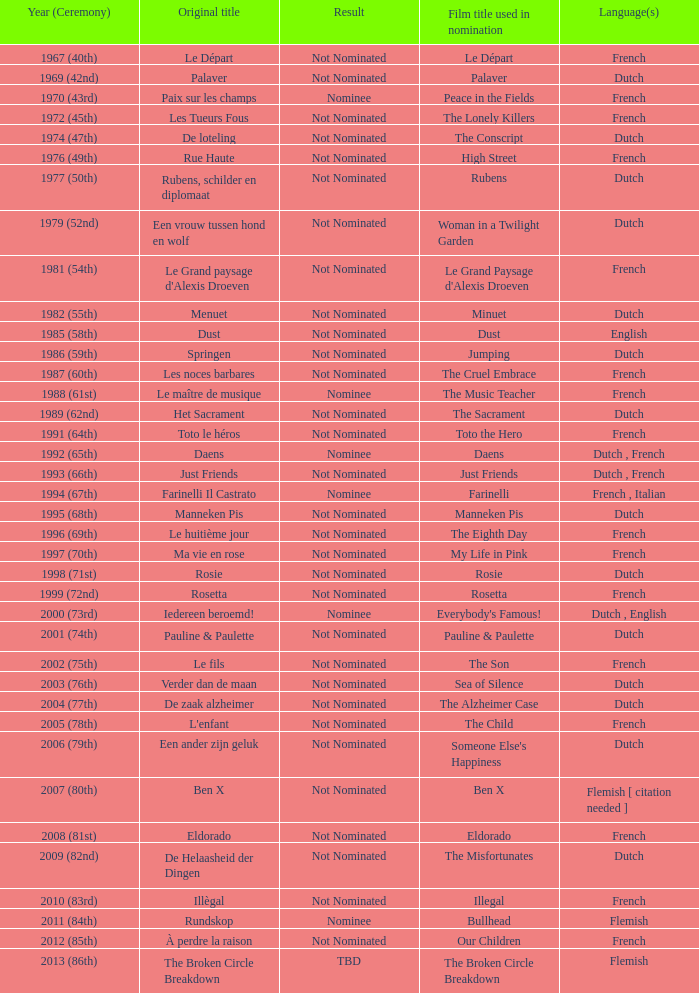What is the language of the film Rosie? Dutch. 